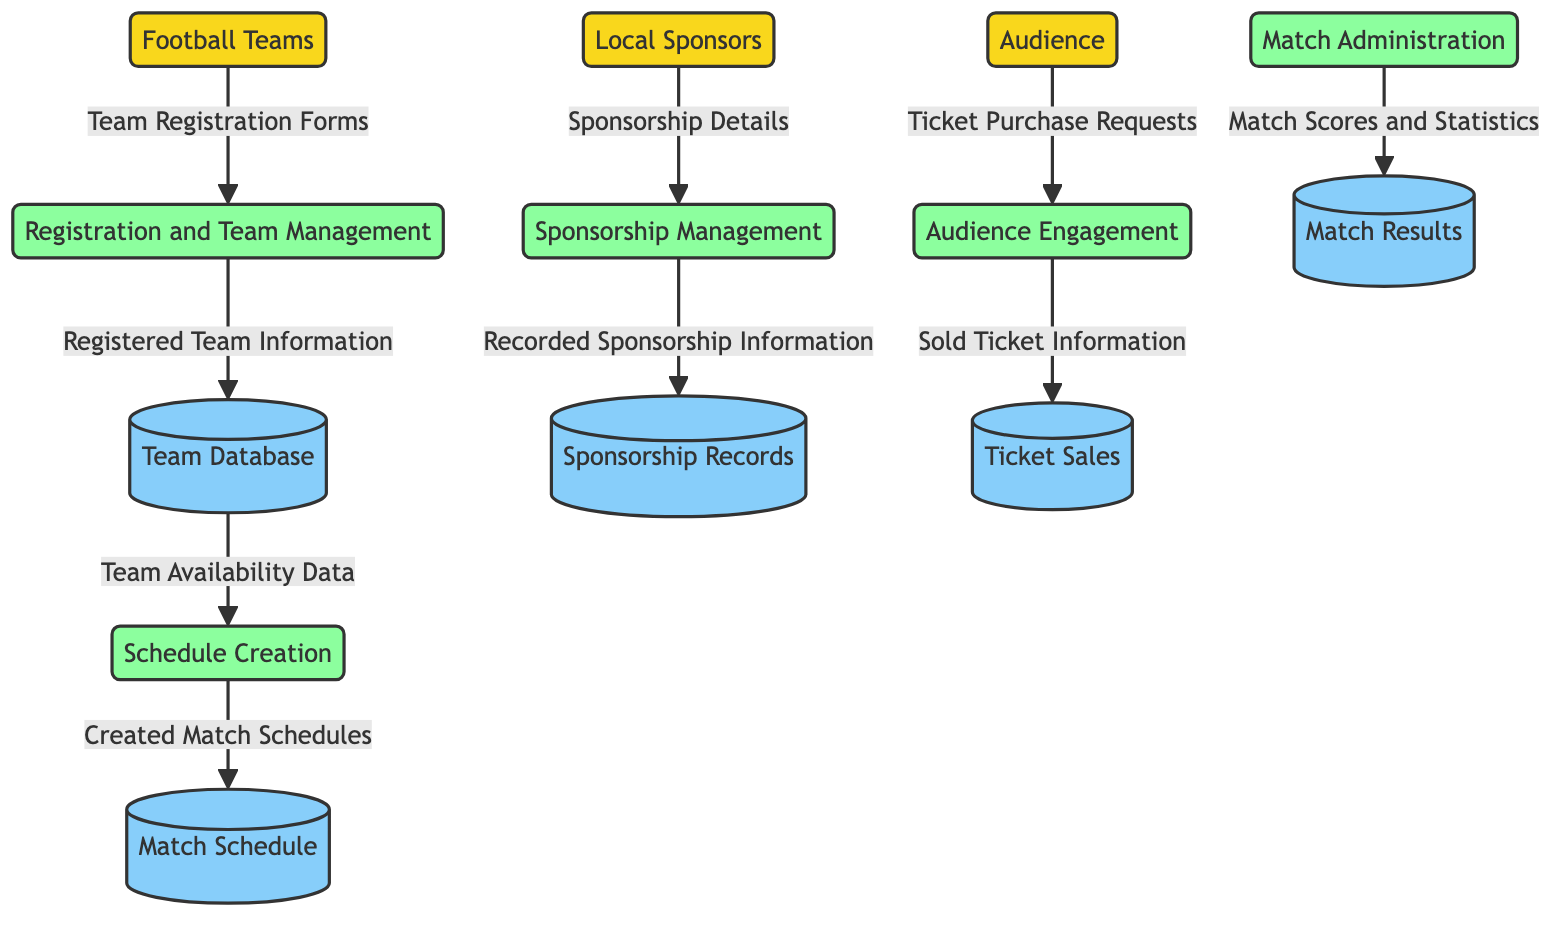What external entity provides financial support? The external entity that provides financial support is indicated in the diagram as "Local Sponsors."
Answer: Local Sponsors How many processes are involved in the tournament management? The diagram shows five processes: Registration and Team Management, Schedule Creation, Match Administration, Sponsorship Management, and Audience Engagement, which totals five.
Answer: Five What is stored in the Team Database? The Team Database contains information about registered teams, players, and contact details, as described in the diagram.
Answer: Registered teams, players, and contact details Which process manages ticket sales? The process that manages ticket sales is labeled "Audience Engagement" in the diagram.
Answer: Audience Engagement What type of information is sent from Football Teams to Registration and Team Management? The diagram indicates that "Team Registration Forms" are sent from Football Teams to the Registration and Team Management process.
Answer: Team Registration Forms What data flows from Match Administration to Match Results? The diagram shows that "Match Scores and Statistics" are the data flowing from Match Administration to Match Results.
Answer: Match Scores and Statistics Which data store records ticket sales? The data store that records ticket sales is designated as "Ticket Sales" in the diagram.
Answer: Ticket Sales How many data stores are there in total? There are five data stores illustrated in the diagram, which are Team Database, Match Schedule, Match Results, Sponsorship Records, and Ticket Sales, adding up to five.
Answer: Five What is the relationship between Sponsorship Management and Sponsorship Records? According to the diagram, the Sponsorship Management process flows into the Sponsorship Records data store, indicating that recorded sponsorship information is stored there.
Answer: Recorded Sponsorship Information 